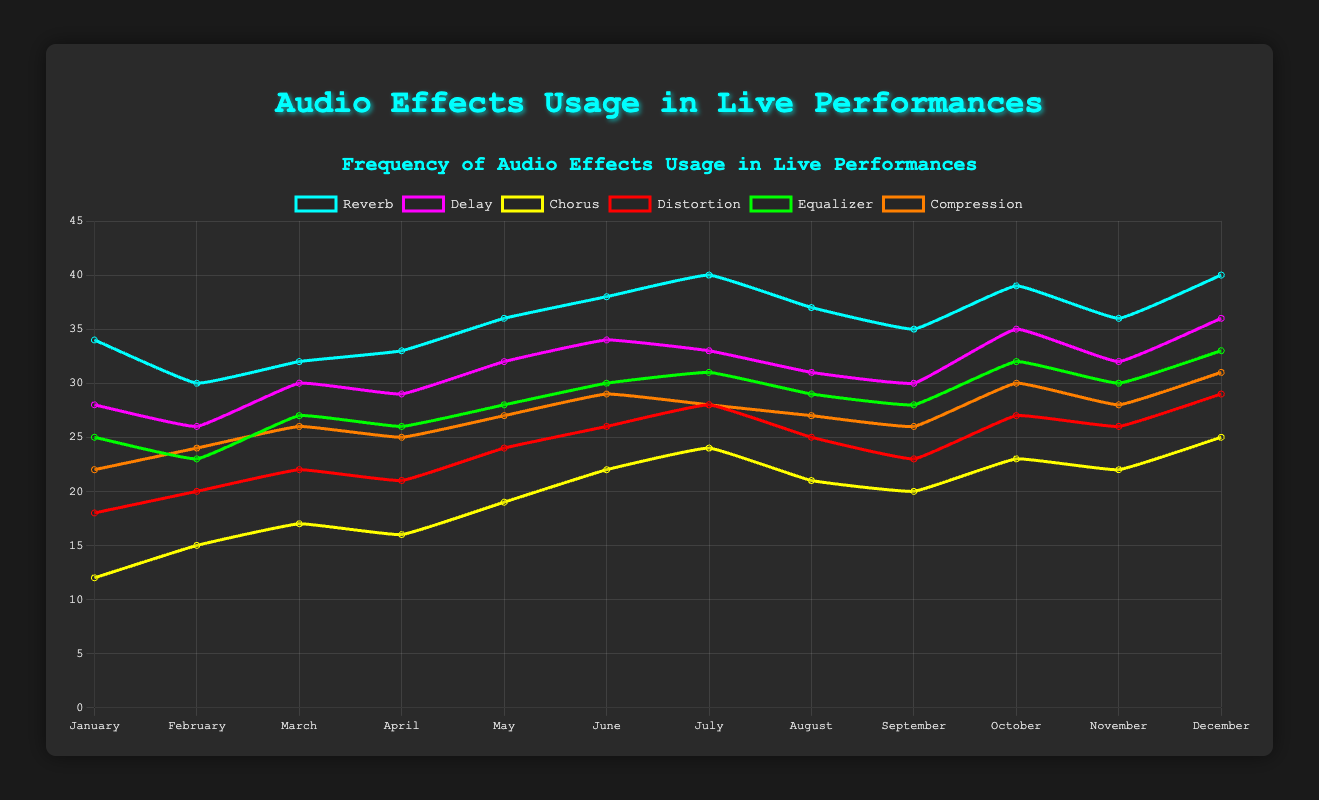What is the highest frequency of any audio effect in the entire year? To find this, identify the maximum value across all effects throughout the months. The highest frequency is 40, which can be seen for Reverb in July and December.
Answer: 40 Which month had the highest usage of the Chorus effect? Look at the Chorus line and identify the month where it peaks. The highest value for Chorus is in December with a frequency of 25.
Answer: December What is the difference in the usage of Delay effect between January and October? Find the values for Delay in January (28) and October (35), then calculate the difference: 35 - 28 = 7.
Answer: 7 On average, how often was the Equalizer used over the year? Add the usage of Equalizer for all months and divide by 12. (25+23+27+26+28+30+31+29+28+32+30+33)/12 ≈ 28.167
Answer: 28.167 Which two effects showed the least fluctuation over the year? Fluctuation can be interpreted as changes in frequency. Delay and Compression have relatively smaller changes compared to other effects when observing the line patterns.
Answer: Delay and Compression Which audio effect showed the most consistent increase over the months? Look at the effects' lines for an upward trend. Reverb shows the most consistent increase without significant drops.
Answer: Reverb Which month shows the peak usage for Distortion and what is the value? Identify the highest point in the Distortion line. The peak usage happens in December with a value of 29.
Answer: December, 29 During which months do Reverb and Compression have the same frequency, and what is the value? Compare the lines for Reverb and Compression. Both lines intersect in July with a frequency of 40 and November with a frequency of 36.
Answer: July and November, 40 and 36 How much did the usage of Compression increase from February to December? Find the values for Compression in February (24) and December (31), then calculate the increase: 31 - 24 = 7.
Answer: 7 